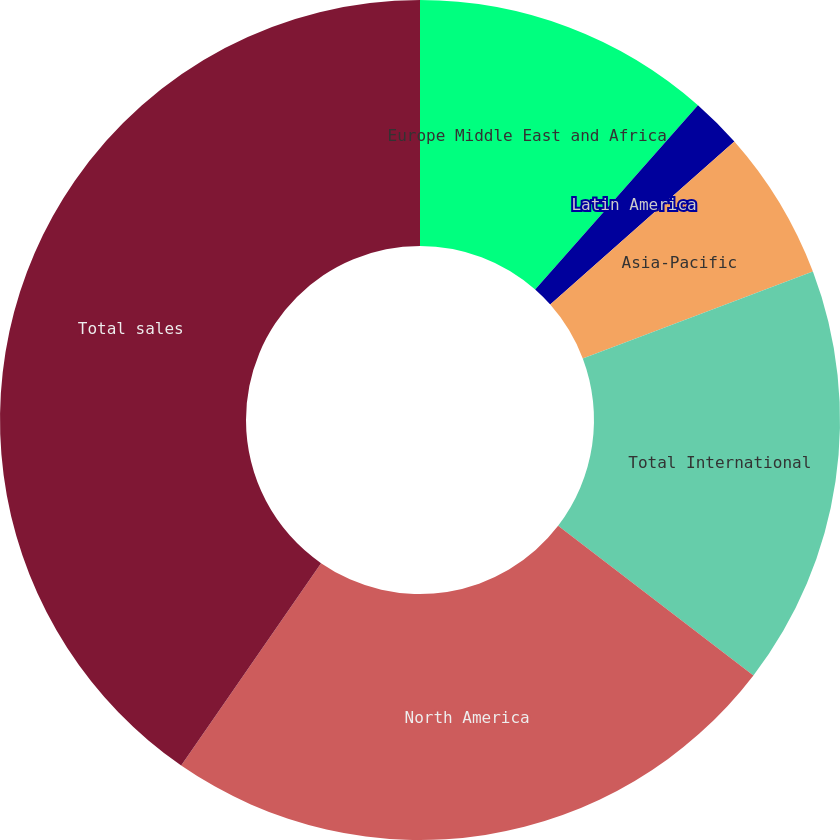Convert chart to OTSL. <chart><loc_0><loc_0><loc_500><loc_500><pie_chart><fcel>Europe Middle East and Africa<fcel>Latin America<fcel>Asia-Pacific<fcel>Total International<fcel>North America<fcel>Total sales<nl><fcel>11.51%<fcel>1.95%<fcel>5.79%<fcel>16.15%<fcel>24.22%<fcel>40.37%<nl></chart> 